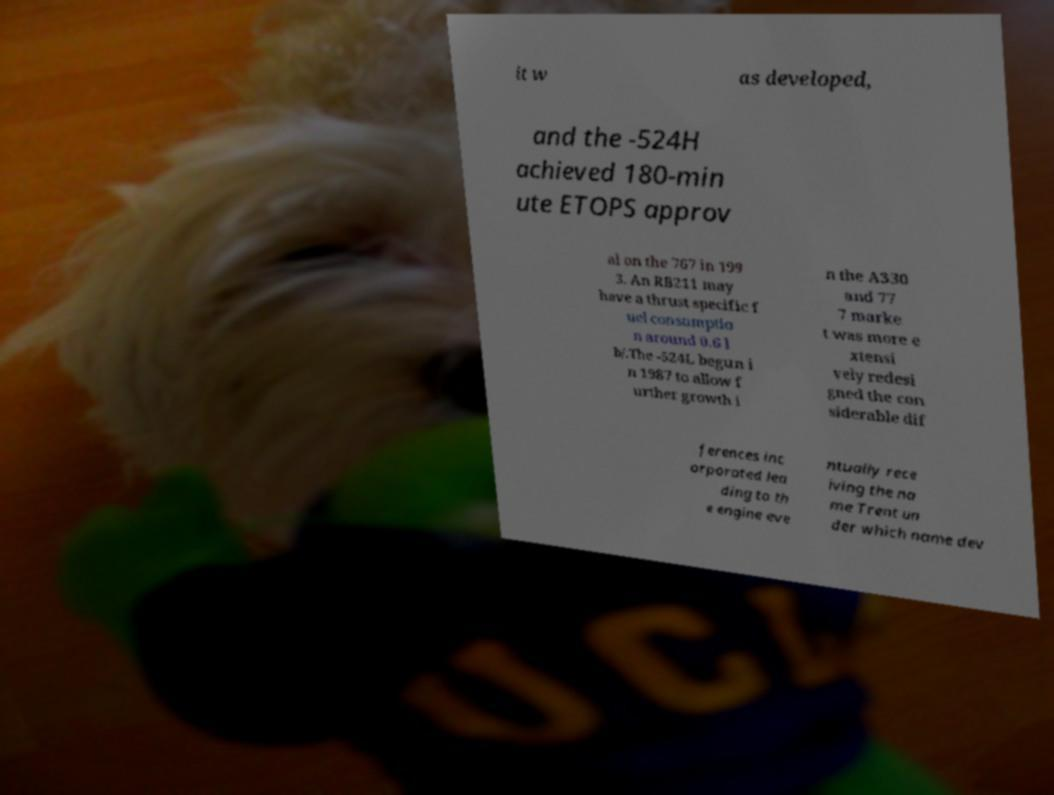Can you read and provide the text displayed in the image?This photo seems to have some interesting text. Can you extract and type it out for me? it w as developed, and the -524H achieved 180-min ute ETOPS approv al on the 767 in 199 3. An RB211 may have a thrust specific f uel consumptio n around 0.6 l b/.The -524L begun i n 1987 to allow f urther growth i n the A330 and 77 7 marke t was more e xtensi vely redesi gned the con siderable dif ferences inc orporated lea ding to th e engine eve ntually rece iving the na me Trent un der which name dev 